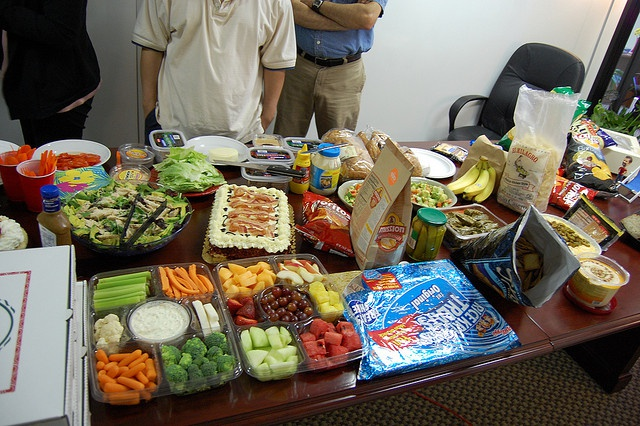Describe the objects in this image and their specific colors. I can see dining table in black, maroon, darkgray, and olive tones, people in black, darkgray, gray, and maroon tones, people in black and gray tones, people in black, maroon, and gray tones, and bowl in black, olive, darkgreen, and gray tones in this image. 